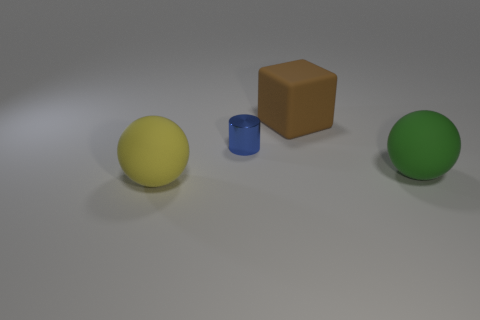Do the small blue thing and the rubber thing in front of the large green sphere have the same shape?
Make the answer very short. No. How many other objects are there of the same material as the block?
Your answer should be very brief. 2. There is a small thing; are there any blocks left of it?
Offer a terse response. No. Does the yellow object have the same size as the object that is behind the blue metallic object?
Offer a very short reply. Yes. There is a rubber sphere that is behind the rubber ball to the left of the large green rubber thing; what is its color?
Provide a short and direct response. Green. Does the blue cylinder have the same size as the rubber block?
Your response must be concise. No. There is a thing that is on the left side of the big cube and in front of the metal cylinder; what color is it?
Your answer should be very brief. Yellow. What size is the blue shiny object?
Provide a succinct answer. Small. Does the large sphere that is right of the small object have the same color as the small shiny object?
Keep it short and to the point. No. Are there more matte objects that are in front of the big brown thing than big yellow matte balls that are right of the blue object?
Give a very brief answer. Yes. 